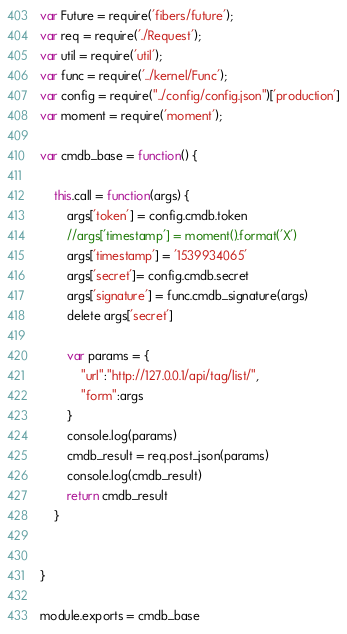Convert code to text. <code><loc_0><loc_0><loc_500><loc_500><_JavaScript_>var Future = require('fibers/future');
var req = require('./Request');
var util = require('util');
var func = require('../kernel/Func');
var config = require("../config/config.json")['production']
var moment = require('moment');

var cmdb_base = function() {

    this.call = function(args) {
        args['token'] = config.cmdb.token
        //args['timestamp'] = moment().format('X')
        args['timestamp'] = '1539934065'
        args['secret']= config.cmdb.secret
        args['signature'] = func.cmdb_signature(args)
        delete args['secret']

        var params = {
            "url":"http://127.0.0.1/api/tag/list/",
            "form":args
        }
        console.log(params)
        cmdb_result = req.post_json(params)
        console.log(cmdb_result)
        return cmdb_result 
    }


}

module.exports = cmdb_base
</code> 